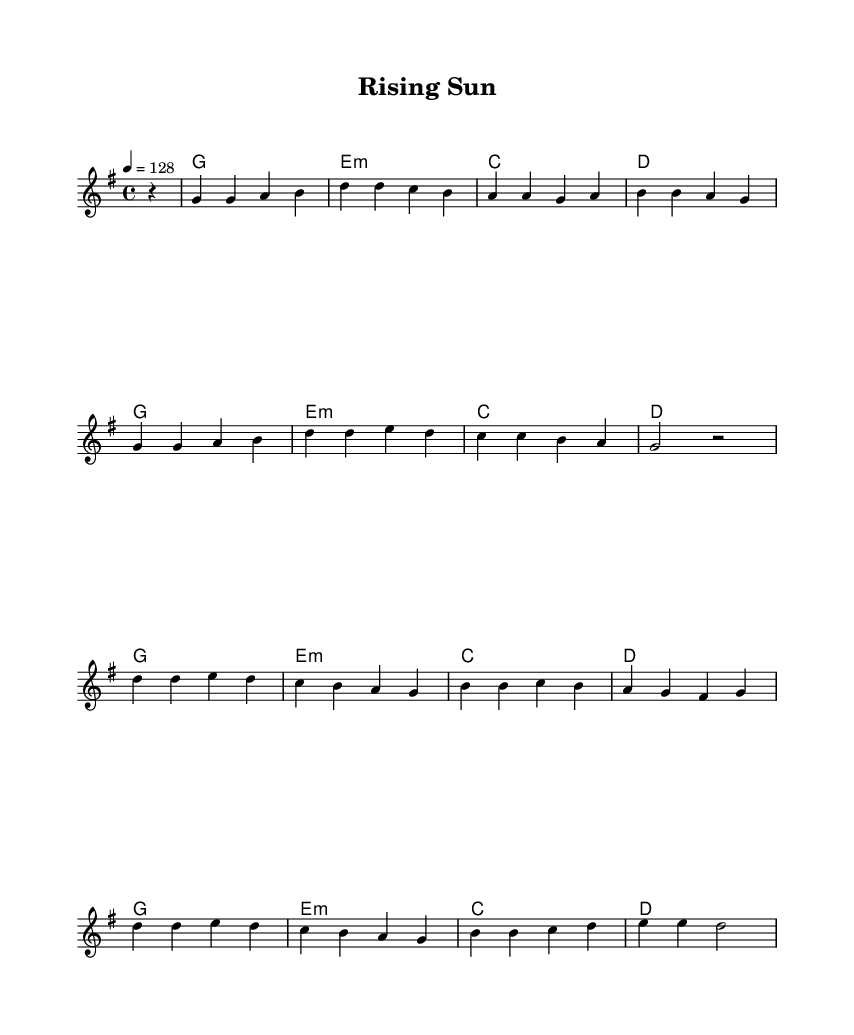What is the key signature of this music? The key signature is G major, which has one sharp (F#). This can be identified by looking at the key signature in the beginning of the sheet music.
Answer: G major What is the time signature of this music? The time signature is 4/4, indicated by the numbers at the beginning of the sheet music. This means there are four beats in each measure, and a quarter note gets one beat.
Answer: 4/4 What is the tempo marking of this piece? The tempo marking indicates a tempo of 128 beats per minute. This is mentioned near the top of the music where the tempo is indicated.
Answer: 128 How many measures are in the melody? By counting the measures in the melody section, we see that there are a total of 8 measures in the provided melody. Each line in the music represents a measure.
Answer: 8 What is the final note of the melody? The final note of the melody is a half note (d) in the last measure, which signifies its duration and placement in the music's structure.
Answer: d2 What is the harmonic progression used in the first four measures? The harmonic progression in the first four measures consists of G, E minor, C, and D. This progression can be identified by observing the chord symbols written above the melody and their order.
Answer: G, E minor, C, D How does the structure of this piece reflect K-Pop characteristics? The structure includes catchy melodies and repetitive chord progressions typical of K-Pop. The upbeat tempo and structured arrangement contribute to the catchy, energetic feel, which is essential in K-Pop music.
Answer: Catchy melodies and repetitive chords 